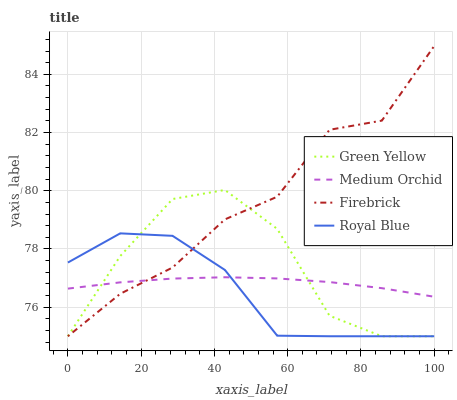Does Royal Blue have the minimum area under the curve?
Answer yes or no. Yes. Does Firebrick have the maximum area under the curve?
Answer yes or no. Yes. Does Medium Orchid have the minimum area under the curve?
Answer yes or no. No. Does Medium Orchid have the maximum area under the curve?
Answer yes or no. No. Is Medium Orchid the smoothest?
Answer yes or no. Yes. Is Green Yellow the roughest?
Answer yes or no. Yes. Is Green Yellow the smoothest?
Answer yes or no. No. Is Medium Orchid the roughest?
Answer yes or no. No. Does Royal Blue have the lowest value?
Answer yes or no. Yes. Does Medium Orchid have the lowest value?
Answer yes or no. No. Does Firebrick have the highest value?
Answer yes or no. Yes. Does Green Yellow have the highest value?
Answer yes or no. No. Does Medium Orchid intersect Royal Blue?
Answer yes or no. Yes. Is Medium Orchid less than Royal Blue?
Answer yes or no. No. Is Medium Orchid greater than Royal Blue?
Answer yes or no. No. 